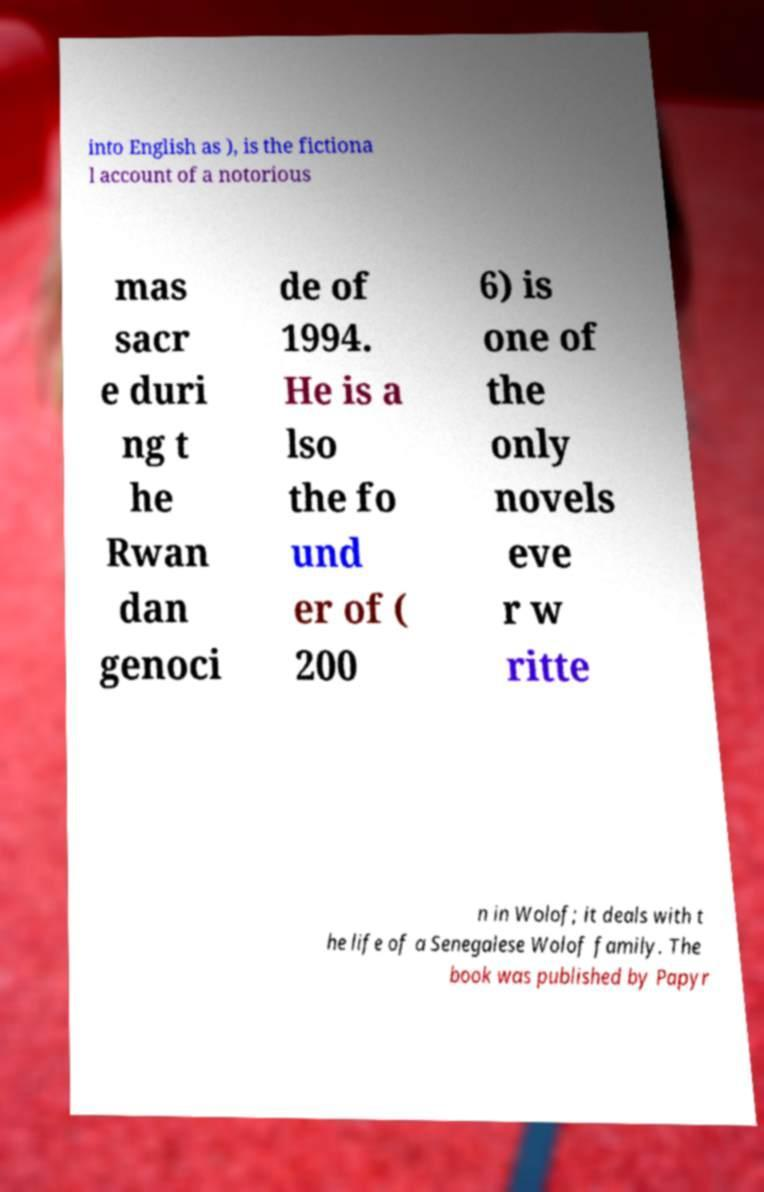I need the written content from this picture converted into text. Can you do that? into English as ), is the fictiona l account of a notorious mas sacr e duri ng t he Rwan dan genoci de of 1994. He is a lso the fo und er of ( 200 6) is one of the only novels eve r w ritte n in Wolof; it deals with t he life of a Senegalese Wolof family. The book was published by Papyr 